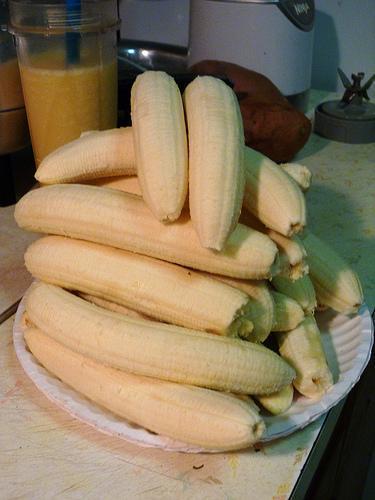How many cups are in the picture?
Give a very brief answer. 1. 